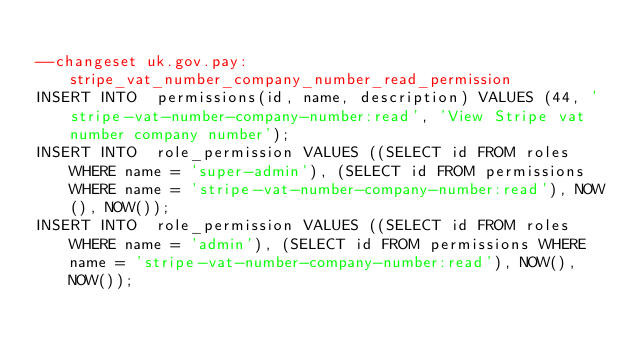<code> <loc_0><loc_0><loc_500><loc_500><_SQL_>
--changeset uk.gov.pay:stripe_vat_number_company_number_read_permission
INSERT INTO  permissions(id, name, description) VALUES (44, 'stripe-vat-number-company-number:read', 'View Stripe vat number company number');
INSERT INTO  role_permission VALUES ((SELECT id FROM roles WHERE name = 'super-admin'), (SELECT id FROM permissions WHERE name = 'stripe-vat-number-company-number:read'), NOW(), NOW());
INSERT INTO  role_permission VALUES ((SELECT id FROM roles WHERE name = 'admin'), (SELECT id FROM permissions WHERE name = 'stripe-vat-number-company-number:read'), NOW(), NOW());
</code> 